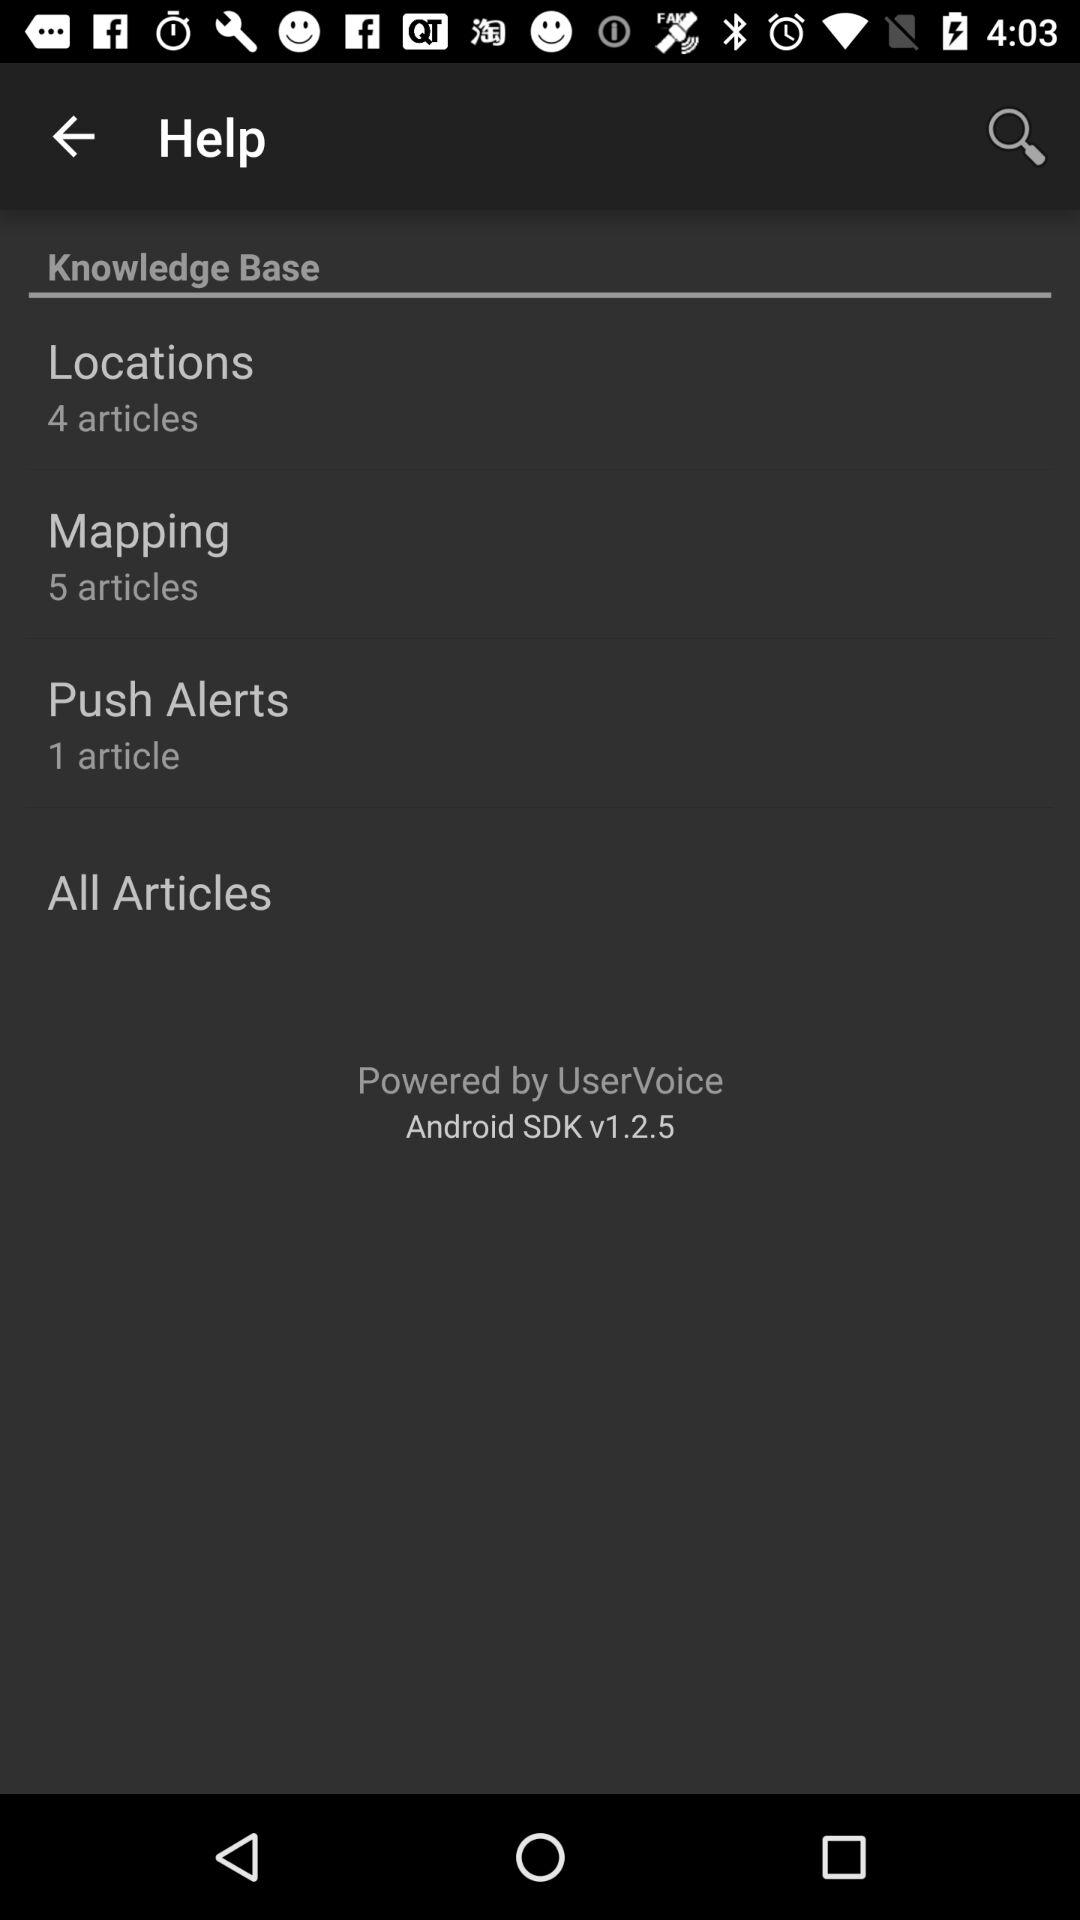How many articles are there in total?
Answer the question using a single word or phrase. 10 